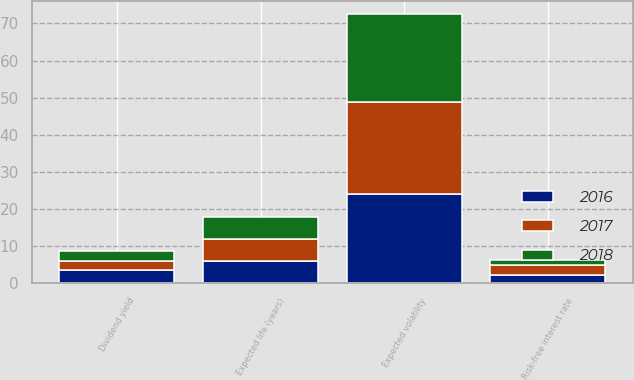Convert chart to OTSL. <chart><loc_0><loc_0><loc_500><loc_500><stacked_bar_chart><ecel><fcel>Expected volatility<fcel>Risk-free interest rate<fcel>Dividend yield<fcel>Expected life (years)<nl><fcel>2017<fcel>24.7<fcel>2.7<fcel>2.4<fcel>5.9<nl><fcel>2016<fcel>24<fcel>2.1<fcel>3.5<fcel>5.9<nl><fcel>2018<fcel>23.7<fcel>1.4<fcel>2.9<fcel>6<nl></chart> 